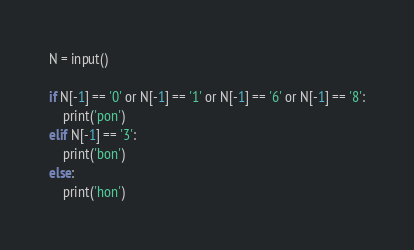Convert code to text. <code><loc_0><loc_0><loc_500><loc_500><_Python_>N = input()

if N[-1] == '0' or N[-1] == '1' or N[-1] == '6' or N[-1] == '8':
    print('pon')
elif N[-1] == '3':
    print('bon')
else:
    print('hon')</code> 